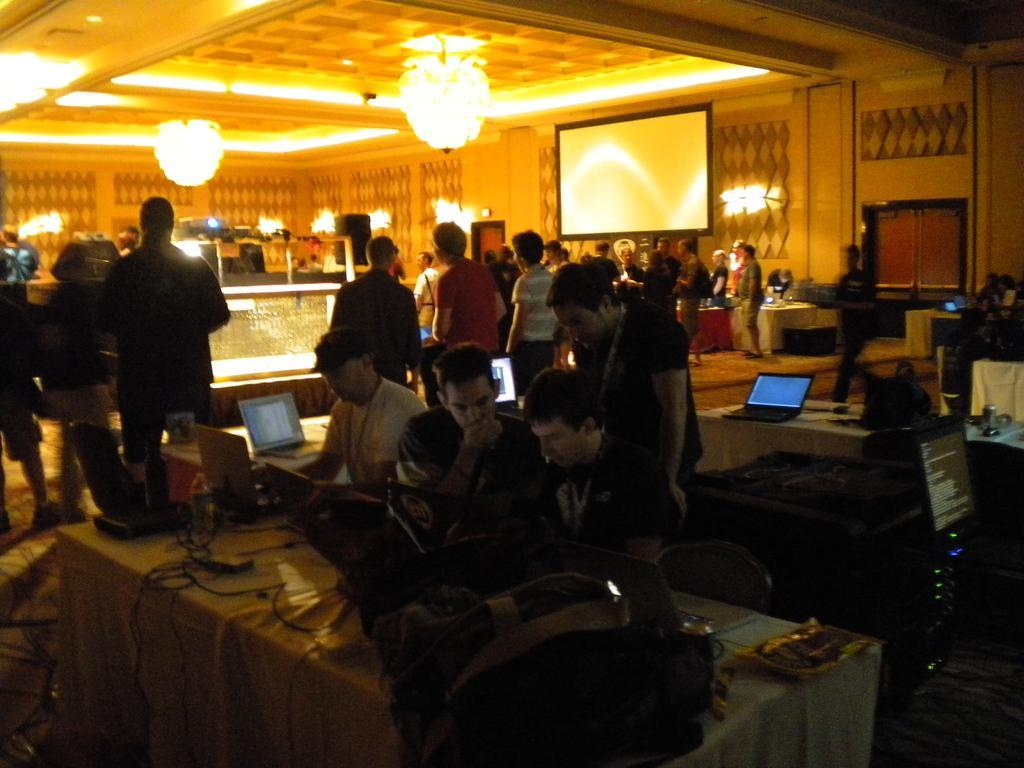Could you give a brief overview of what you see in this image? In this image, I can see few people standing and few people sitting. These are the tables with laptop, bag, cables and few other things on it. This is a screen. I think these are the ceiling lights, which are hanging to the ceiling. Here is a person holding an object and walking. These look like the doors. 